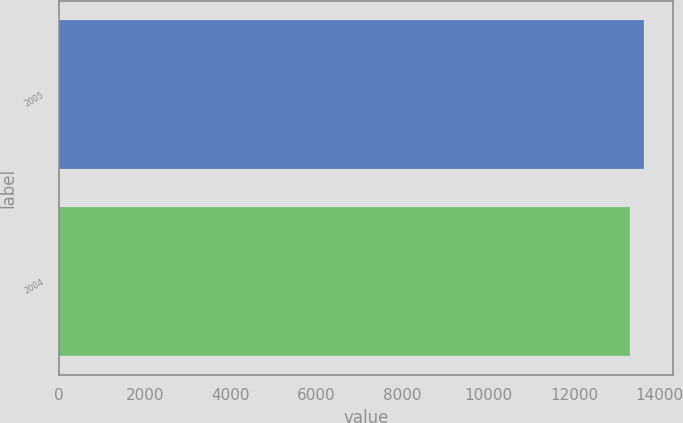Convert chart to OTSL. <chart><loc_0><loc_0><loc_500><loc_500><bar_chart><fcel>2005<fcel>2004<nl><fcel>13623<fcel>13317<nl></chart> 